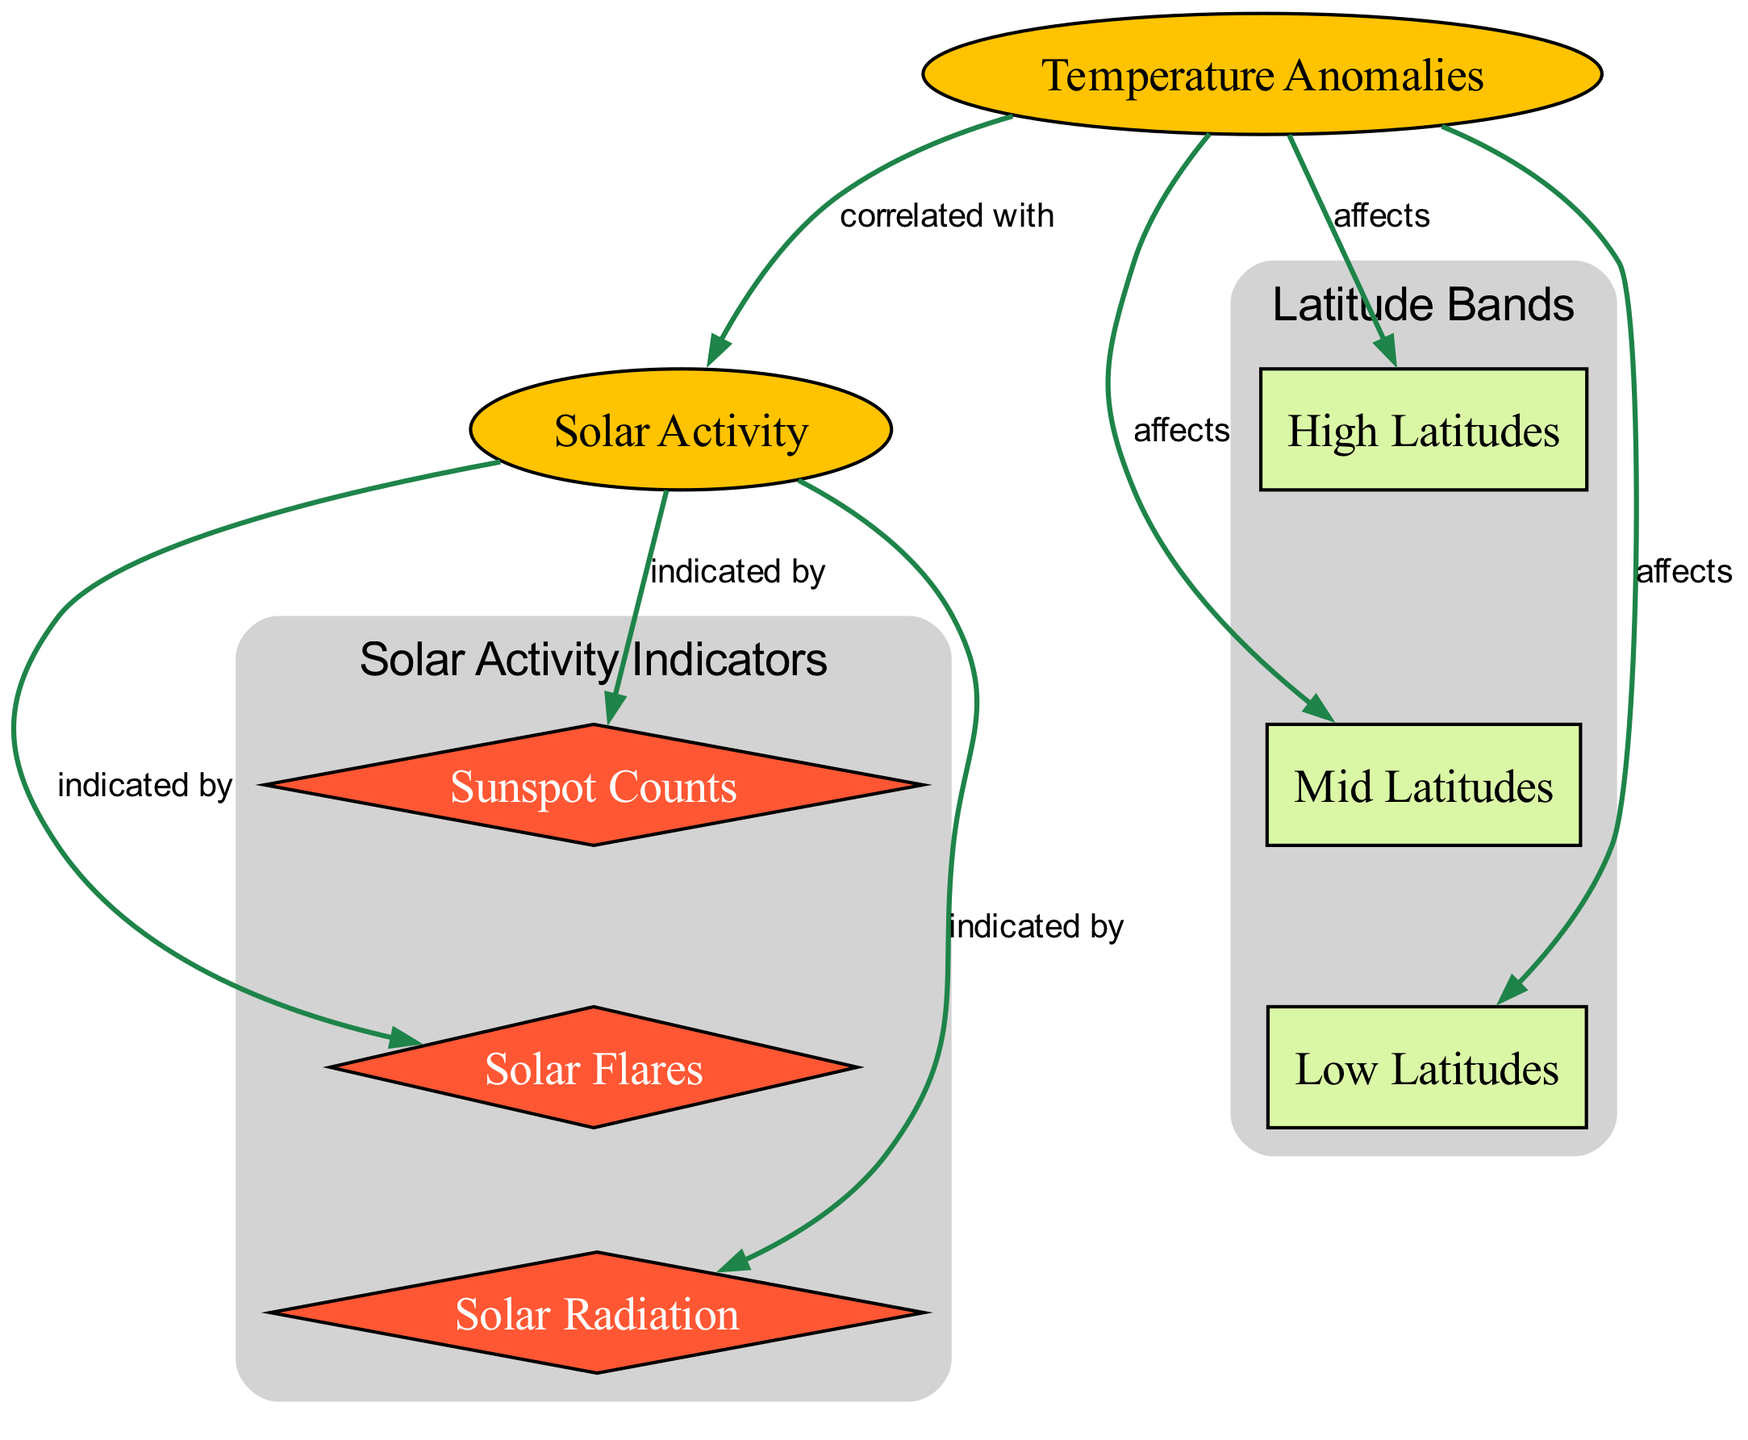What is the central theme of the diagram? The central theme is the correlation between temperature anomalies and solar activity across different latitude bands. This theme is represented by the central nodes "Temperature Anomalies" and "Solar Activity," which are the primary focus of the diagram.
Answer: correlation between temperature anomalies and solar activity How many latitude bands are represented in the diagram? The diagram includes three latitude bands: High Latitudes, Mid Latitudes, and Low Latitudes. Each latitude band is distinctly represented, and their connections to temperature anomalies are shown.
Answer: three What type of nodes represent solar activity indicators? The solar activity indicators are represented by diamond-shaped nodes, which in this case are "Sunspot Counts," "Solar Flares," and "Solar Radiation." These shape types indicate correlated data in the diagram.
Answer: diamond-shaped nodes Which latitude band is indicated to be affected by temperature anomalies? All latitude bands (High Latitudes, Mid Latitudes, and Low Latitudes) are indicated to be affected by temperature anomalies. This is shown through the edges connecting the temperature anomalies node to each latitude band node.
Answer: High Latitudes, Mid Latitudes, Low Latitudes What does “indicated by” refer to in the relationships shown? The phrase “indicated by” refers to how solar activity is displayed or measured through specific aspects such as "Sunspot Counts," "Solar Flares," and "Solar Radiation." These nodes provide quantitative and qualitative data to understand solar activity.
Answer: Sunspot Counts, Solar Flares, Solar Radiation How many edges connect Temperature Anomalies to latitude bands? There are three edges that connect Temperature Anomalies to each of the latitude bands (High Latitudes, Mid Latitudes, and Low Latitudes), indicating their respective relationships.
Answer: three What type of relationship is shown between Temperature Anomalies and Solar Activity? The relationship between Temperature Anomalies and Solar Activity is described as "correlated with," which signifies that changes in one may influence or relate to changes in the other.
Answer: correlated with Which node has the highest visual indication of causality in the diagram? The node "Temperature Anomalies" shows the highest visual indication of causality, as it is the central focus and affects all latitude bands, highlighting its primary role in understanding the diagram's implications.
Answer: Temperature Anomalies 